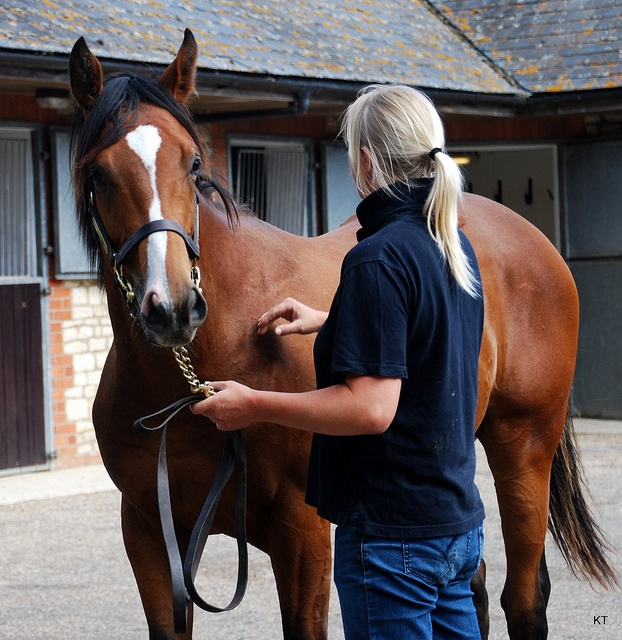Describe the objects in this image and their specific colors. I can see horse in gray, black, maroon, and brown tones and people in gray, black, navy, maroon, and lightgray tones in this image. 